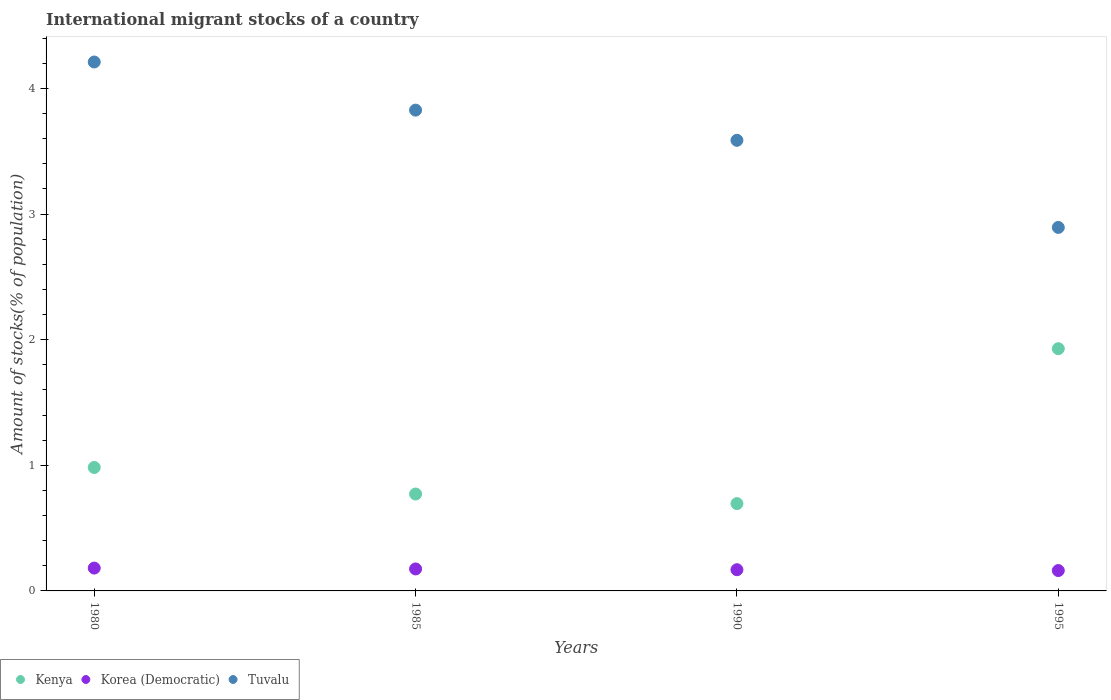Is the number of dotlines equal to the number of legend labels?
Ensure brevity in your answer.  Yes. What is the amount of stocks in in Tuvalu in 1995?
Your response must be concise. 2.89. Across all years, what is the maximum amount of stocks in in Kenya?
Your answer should be compact. 1.93. Across all years, what is the minimum amount of stocks in in Kenya?
Your answer should be very brief. 0.7. In which year was the amount of stocks in in Kenya maximum?
Offer a very short reply. 1995. In which year was the amount of stocks in in Kenya minimum?
Keep it short and to the point. 1990. What is the total amount of stocks in in Kenya in the graph?
Offer a very short reply. 4.38. What is the difference between the amount of stocks in in Tuvalu in 1980 and that in 1995?
Provide a short and direct response. 1.32. What is the difference between the amount of stocks in in Kenya in 1990 and the amount of stocks in in Tuvalu in 1980?
Provide a succinct answer. -3.52. What is the average amount of stocks in in Kenya per year?
Make the answer very short. 1.09. In the year 1980, what is the difference between the amount of stocks in in Kenya and amount of stocks in in Korea (Democratic)?
Provide a short and direct response. 0.8. In how many years, is the amount of stocks in in Korea (Democratic) greater than 0.2 %?
Provide a short and direct response. 0. What is the ratio of the amount of stocks in in Kenya in 1985 to that in 1990?
Make the answer very short. 1.11. Is the amount of stocks in in Korea (Democratic) in 1985 less than that in 1990?
Your answer should be compact. No. What is the difference between the highest and the second highest amount of stocks in in Korea (Democratic)?
Provide a succinct answer. 0.01. What is the difference between the highest and the lowest amount of stocks in in Korea (Democratic)?
Provide a short and direct response. 0.02. In how many years, is the amount of stocks in in Tuvalu greater than the average amount of stocks in in Tuvalu taken over all years?
Provide a succinct answer. 2. Is the amount of stocks in in Kenya strictly less than the amount of stocks in in Korea (Democratic) over the years?
Offer a terse response. No. Does the graph contain any zero values?
Ensure brevity in your answer.  No. Where does the legend appear in the graph?
Make the answer very short. Bottom left. How many legend labels are there?
Provide a short and direct response. 3. How are the legend labels stacked?
Your answer should be compact. Horizontal. What is the title of the graph?
Offer a terse response. International migrant stocks of a country. Does "Kenya" appear as one of the legend labels in the graph?
Make the answer very short. Yes. What is the label or title of the Y-axis?
Your answer should be very brief. Amount of stocks(% of population). What is the Amount of stocks(% of population) in Kenya in 1980?
Provide a short and direct response. 0.98. What is the Amount of stocks(% of population) of Korea (Democratic) in 1980?
Provide a short and direct response. 0.18. What is the Amount of stocks(% of population) of Tuvalu in 1980?
Provide a short and direct response. 4.21. What is the Amount of stocks(% of population) in Kenya in 1985?
Your response must be concise. 0.77. What is the Amount of stocks(% of population) in Korea (Democratic) in 1985?
Your response must be concise. 0.17. What is the Amount of stocks(% of population) in Tuvalu in 1985?
Provide a short and direct response. 3.83. What is the Amount of stocks(% of population) of Kenya in 1990?
Provide a short and direct response. 0.7. What is the Amount of stocks(% of population) of Korea (Democratic) in 1990?
Your answer should be very brief. 0.17. What is the Amount of stocks(% of population) in Tuvalu in 1990?
Your answer should be very brief. 3.59. What is the Amount of stocks(% of population) of Kenya in 1995?
Ensure brevity in your answer.  1.93. What is the Amount of stocks(% of population) of Korea (Democratic) in 1995?
Your answer should be very brief. 0.16. What is the Amount of stocks(% of population) of Tuvalu in 1995?
Make the answer very short. 2.89. Across all years, what is the maximum Amount of stocks(% of population) in Kenya?
Give a very brief answer. 1.93. Across all years, what is the maximum Amount of stocks(% of population) in Korea (Democratic)?
Offer a terse response. 0.18. Across all years, what is the maximum Amount of stocks(% of population) of Tuvalu?
Offer a terse response. 4.21. Across all years, what is the minimum Amount of stocks(% of population) of Kenya?
Make the answer very short. 0.7. Across all years, what is the minimum Amount of stocks(% of population) of Korea (Democratic)?
Provide a succinct answer. 0.16. Across all years, what is the minimum Amount of stocks(% of population) of Tuvalu?
Your answer should be very brief. 2.89. What is the total Amount of stocks(% of population) of Kenya in the graph?
Give a very brief answer. 4.38. What is the total Amount of stocks(% of population) in Korea (Democratic) in the graph?
Ensure brevity in your answer.  0.69. What is the total Amount of stocks(% of population) in Tuvalu in the graph?
Your answer should be very brief. 14.52. What is the difference between the Amount of stocks(% of population) in Kenya in 1980 and that in 1985?
Provide a succinct answer. 0.21. What is the difference between the Amount of stocks(% of population) in Korea (Democratic) in 1980 and that in 1985?
Offer a very short reply. 0.01. What is the difference between the Amount of stocks(% of population) of Tuvalu in 1980 and that in 1985?
Give a very brief answer. 0.38. What is the difference between the Amount of stocks(% of population) in Kenya in 1980 and that in 1990?
Provide a short and direct response. 0.29. What is the difference between the Amount of stocks(% of population) in Korea (Democratic) in 1980 and that in 1990?
Provide a succinct answer. 0.01. What is the difference between the Amount of stocks(% of population) in Tuvalu in 1980 and that in 1990?
Make the answer very short. 0.62. What is the difference between the Amount of stocks(% of population) of Kenya in 1980 and that in 1995?
Your response must be concise. -0.95. What is the difference between the Amount of stocks(% of population) in Korea (Democratic) in 1980 and that in 1995?
Provide a short and direct response. 0.02. What is the difference between the Amount of stocks(% of population) of Tuvalu in 1980 and that in 1995?
Provide a succinct answer. 1.32. What is the difference between the Amount of stocks(% of population) of Kenya in 1985 and that in 1990?
Ensure brevity in your answer.  0.08. What is the difference between the Amount of stocks(% of population) of Korea (Democratic) in 1985 and that in 1990?
Your response must be concise. 0.01. What is the difference between the Amount of stocks(% of population) in Tuvalu in 1985 and that in 1990?
Your response must be concise. 0.24. What is the difference between the Amount of stocks(% of population) of Kenya in 1985 and that in 1995?
Your answer should be compact. -1.16. What is the difference between the Amount of stocks(% of population) in Korea (Democratic) in 1985 and that in 1995?
Ensure brevity in your answer.  0.01. What is the difference between the Amount of stocks(% of population) of Tuvalu in 1985 and that in 1995?
Provide a succinct answer. 0.93. What is the difference between the Amount of stocks(% of population) in Kenya in 1990 and that in 1995?
Make the answer very short. -1.23. What is the difference between the Amount of stocks(% of population) of Korea (Democratic) in 1990 and that in 1995?
Provide a succinct answer. 0.01. What is the difference between the Amount of stocks(% of population) of Tuvalu in 1990 and that in 1995?
Your answer should be very brief. 0.69. What is the difference between the Amount of stocks(% of population) of Kenya in 1980 and the Amount of stocks(% of population) of Korea (Democratic) in 1985?
Your response must be concise. 0.81. What is the difference between the Amount of stocks(% of population) in Kenya in 1980 and the Amount of stocks(% of population) in Tuvalu in 1985?
Your answer should be very brief. -2.84. What is the difference between the Amount of stocks(% of population) of Korea (Democratic) in 1980 and the Amount of stocks(% of population) of Tuvalu in 1985?
Your answer should be compact. -3.65. What is the difference between the Amount of stocks(% of population) of Kenya in 1980 and the Amount of stocks(% of population) of Korea (Democratic) in 1990?
Your response must be concise. 0.81. What is the difference between the Amount of stocks(% of population) in Kenya in 1980 and the Amount of stocks(% of population) in Tuvalu in 1990?
Offer a very short reply. -2.6. What is the difference between the Amount of stocks(% of population) in Korea (Democratic) in 1980 and the Amount of stocks(% of population) in Tuvalu in 1990?
Your response must be concise. -3.41. What is the difference between the Amount of stocks(% of population) of Kenya in 1980 and the Amount of stocks(% of population) of Korea (Democratic) in 1995?
Provide a succinct answer. 0.82. What is the difference between the Amount of stocks(% of population) in Kenya in 1980 and the Amount of stocks(% of population) in Tuvalu in 1995?
Offer a terse response. -1.91. What is the difference between the Amount of stocks(% of population) of Korea (Democratic) in 1980 and the Amount of stocks(% of population) of Tuvalu in 1995?
Give a very brief answer. -2.71. What is the difference between the Amount of stocks(% of population) in Kenya in 1985 and the Amount of stocks(% of population) in Korea (Democratic) in 1990?
Ensure brevity in your answer.  0.6. What is the difference between the Amount of stocks(% of population) in Kenya in 1985 and the Amount of stocks(% of population) in Tuvalu in 1990?
Ensure brevity in your answer.  -2.82. What is the difference between the Amount of stocks(% of population) of Korea (Democratic) in 1985 and the Amount of stocks(% of population) of Tuvalu in 1990?
Give a very brief answer. -3.41. What is the difference between the Amount of stocks(% of population) of Kenya in 1985 and the Amount of stocks(% of population) of Korea (Democratic) in 1995?
Keep it short and to the point. 0.61. What is the difference between the Amount of stocks(% of population) in Kenya in 1985 and the Amount of stocks(% of population) in Tuvalu in 1995?
Offer a terse response. -2.12. What is the difference between the Amount of stocks(% of population) in Korea (Democratic) in 1985 and the Amount of stocks(% of population) in Tuvalu in 1995?
Your answer should be compact. -2.72. What is the difference between the Amount of stocks(% of population) of Kenya in 1990 and the Amount of stocks(% of population) of Korea (Democratic) in 1995?
Offer a terse response. 0.53. What is the difference between the Amount of stocks(% of population) in Kenya in 1990 and the Amount of stocks(% of population) in Tuvalu in 1995?
Your answer should be compact. -2.2. What is the difference between the Amount of stocks(% of population) in Korea (Democratic) in 1990 and the Amount of stocks(% of population) in Tuvalu in 1995?
Provide a succinct answer. -2.72. What is the average Amount of stocks(% of population) in Kenya per year?
Provide a succinct answer. 1.09. What is the average Amount of stocks(% of population) of Korea (Democratic) per year?
Offer a very short reply. 0.17. What is the average Amount of stocks(% of population) in Tuvalu per year?
Provide a succinct answer. 3.63. In the year 1980, what is the difference between the Amount of stocks(% of population) in Kenya and Amount of stocks(% of population) in Korea (Democratic)?
Keep it short and to the point. 0.8. In the year 1980, what is the difference between the Amount of stocks(% of population) in Kenya and Amount of stocks(% of population) in Tuvalu?
Offer a very short reply. -3.23. In the year 1980, what is the difference between the Amount of stocks(% of population) in Korea (Democratic) and Amount of stocks(% of population) in Tuvalu?
Provide a short and direct response. -4.03. In the year 1985, what is the difference between the Amount of stocks(% of population) in Kenya and Amount of stocks(% of population) in Korea (Democratic)?
Your response must be concise. 0.6. In the year 1985, what is the difference between the Amount of stocks(% of population) of Kenya and Amount of stocks(% of population) of Tuvalu?
Offer a terse response. -3.06. In the year 1985, what is the difference between the Amount of stocks(% of population) in Korea (Democratic) and Amount of stocks(% of population) in Tuvalu?
Provide a short and direct response. -3.65. In the year 1990, what is the difference between the Amount of stocks(% of population) in Kenya and Amount of stocks(% of population) in Korea (Democratic)?
Offer a very short reply. 0.53. In the year 1990, what is the difference between the Amount of stocks(% of population) of Kenya and Amount of stocks(% of population) of Tuvalu?
Your answer should be very brief. -2.89. In the year 1990, what is the difference between the Amount of stocks(% of population) of Korea (Democratic) and Amount of stocks(% of population) of Tuvalu?
Your response must be concise. -3.42. In the year 1995, what is the difference between the Amount of stocks(% of population) of Kenya and Amount of stocks(% of population) of Korea (Democratic)?
Provide a succinct answer. 1.77. In the year 1995, what is the difference between the Amount of stocks(% of population) of Kenya and Amount of stocks(% of population) of Tuvalu?
Offer a terse response. -0.97. In the year 1995, what is the difference between the Amount of stocks(% of population) in Korea (Democratic) and Amount of stocks(% of population) in Tuvalu?
Offer a very short reply. -2.73. What is the ratio of the Amount of stocks(% of population) of Kenya in 1980 to that in 1985?
Give a very brief answer. 1.27. What is the ratio of the Amount of stocks(% of population) in Korea (Democratic) in 1980 to that in 1985?
Keep it short and to the point. 1.04. What is the ratio of the Amount of stocks(% of population) of Tuvalu in 1980 to that in 1985?
Keep it short and to the point. 1.1. What is the ratio of the Amount of stocks(% of population) of Kenya in 1980 to that in 1990?
Make the answer very short. 1.41. What is the ratio of the Amount of stocks(% of population) in Korea (Democratic) in 1980 to that in 1990?
Ensure brevity in your answer.  1.08. What is the ratio of the Amount of stocks(% of population) of Tuvalu in 1980 to that in 1990?
Provide a short and direct response. 1.17. What is the ratio of the Amount of stocks(% of population) in Kenya in 1980 to that in 1995?
Give a very brief answer. 0.51. What is the ratio of the Amount of stocks(% of population) of Korea (Democratic) in 1980 to that in 1995?
Ensure brevity in your answer.  1.12. What is the ratio of the Amount of stocks(% of population) of Tuvalu in 1980 to that in 1995?
Your response must be concise. 1.46. What is the ratio of the Amount of stocks(% of population) in Kenya in 1985 to that in 1990?
Provide a succinct answer. 1.11. What is the ratio of the Amount of stocks(% of population) in Korea (Democratic) in 1985 to that in 1990?
Your response must be concise. 1.04. What is the ratio of the Amount of stocks(% of population) in Tuvalu in 1985 to that in 1990?
Ensure brevity in your answer.  1.07. What is the ratio of the Amount of stocks(% of population) in Kenya in 1985 to that in 1995?
Make the answer very short. 0.4. What is the ratio of the Amount of stocks(% of population) of Korea (Democratic) in 1985 to that in 1995?
Your response must be concise. 1.08. What is the ratio of the Amount of stocks(% of population) of Tuvalu in 1985 to that in 1995?
Ensure brevity in your answer.  1.32. What is the ratio of the Amount of stocks(% of population) in Kenya in 1990 to that in 1995?
Your response must be concise. 0.36. What is the ratio of the Amount of stocks(% of population) of Korea (Democratic) in 1990 to that in 1995?
Keep it short and to the point. 1.04. What is the ratio of the Amount of stocks(% of population) in Tuvalu in 1990 to that in 1995?
Keep it short and to the point. 1.24. What is the difference between the highest and the second highest Amount of stocks(% of population) of Kenya?
Offer a terse response. 0.95. What is the difference between the highest and the second highest Amount of stocks(% of population) of Korea (Democratic)?
Provide a short and direct response. 0.01. What is the difference between the highest and the second highest Amount of stocks(% of population) of Tuvalu?
Offer a terse response. 0.38. What is the difference between the highest and the lowest Amount of stocks(% of population) of Kenya?
Offer a very short reply. 1.23. What is the difference between the highest and the lowest Amount of stocks(% of population) of Korea (Democratic)?
Offer a very short reply. 0.02. What is the difference between the highest and the lowest Amount of stocks(% of population) in Tuvalu?
Your answer should be very brief. 1.32. 